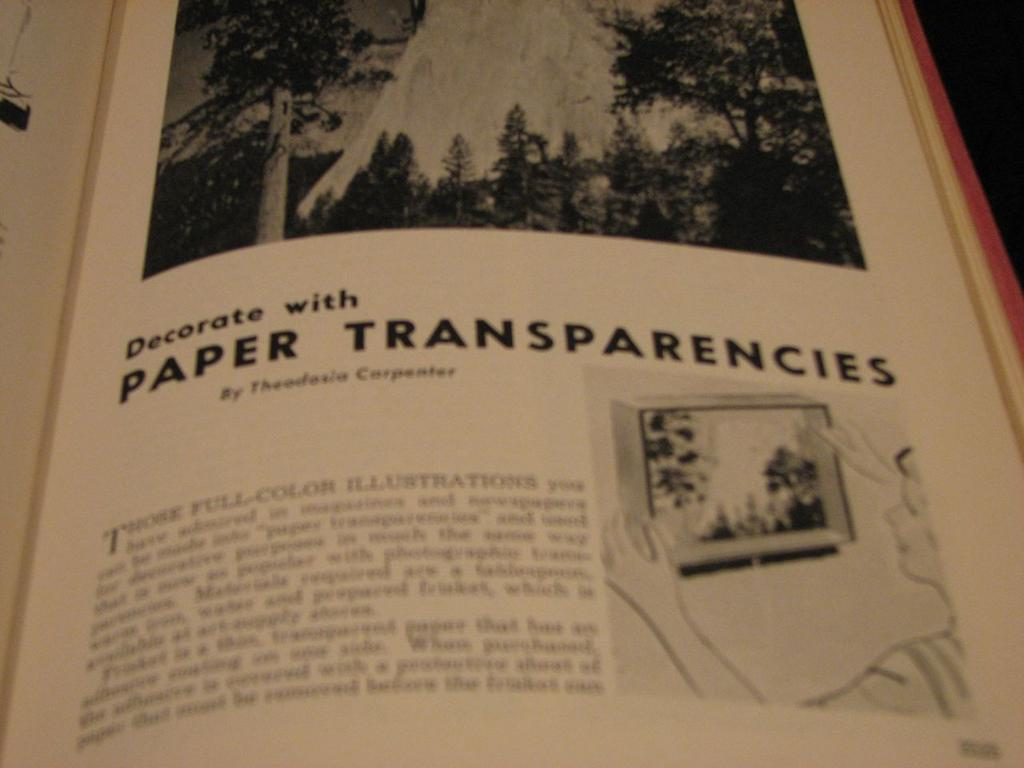<image>
Give a short and clear explanation of the subsequent image. An open book with some pictures that reads Decorite with PAPER TRANSPARENCIES 